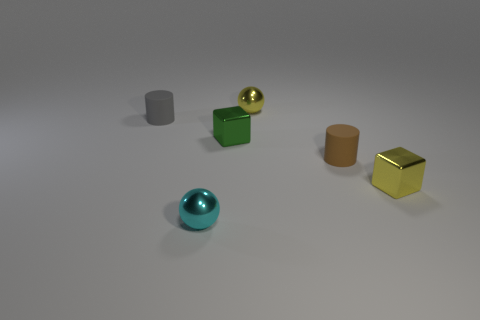What number of tiny yellow metal blocks are there?
Provide a succinct answer. 1. What number of cylinders are big cyan objects or small matte objects?
Offer a very short reply. 2. What number of spheres are in front of the matte thing to the left of the ball behind the small green metal block?
Keep it short and to the point. 1. What is the color of the other metallic sphere that is the same size as the cyan sphere?
Make the answer very short. Yellow. Is the number of matte cylinders that are to the right of the gray rubber object greater than the number of large brown matte blocks?
Give a very brief answer. Yes. Is the small gray object made of the same material as the yellow cube?
Provide a succinct answer. No. How many things are either things on the left side of the brown rubber cylinder or rubber cylinders?
Provide a short and direct response. 5. What number of other things are there of the same size as the gray object?
Your answer should be compact. 5. Is the number of tiny brown objects to the left of the tiny gray rubber cylinder the same as the number of tiny metal things behind the brown matte cylinder?
Offer a terse response. No. What is the color of the other small thing that is the same shape as the small gray thing?
Your answer should be compact. Brown. 